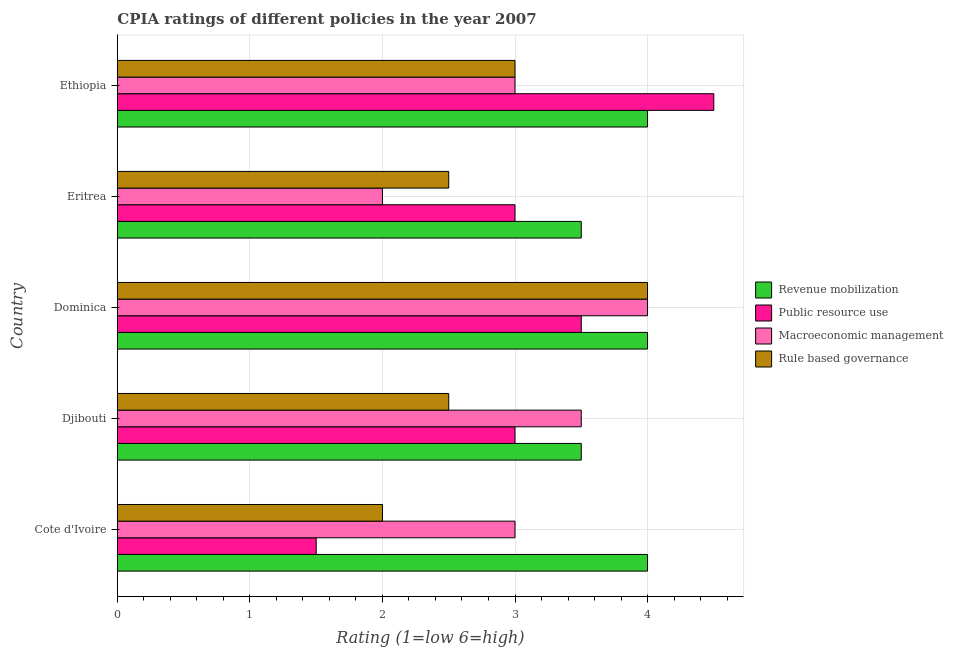How many bars are there on the 5th tick from the top?
Provide a succinct answer. 4. What is the label of the 3rd group of bars from the top?
Keep it short and to the point. Dominica. Across all countries, what is the maximum cpia rating of macroeconomic management?
Offer a terse response. 4. Across all countries, what is the minimum cpia rating of public resource use?
Provide a succinct answer. 1.5. In which country was the cpia rating of public resource use maximum?
Offer a terse response. Ethiopia. In which country was the cpia rating of revenue mobilization minimum?
Your answer should be compact. Djibouti. What is the total cpia rating of macroeconomic management in the graph?
Provide a succinct answer. 15.5. What is the difference between the cpia rating of revenue mobilization in Ethiopia and the cpia rating of macroeconomic management in Dominica?
Provide a succinct answer. 0. What is the ratio of the cpia rating of rule based governance in Dominica to that in Eritrea?
Your answer should be very brief. 1.6. Is the cpia rating of macroeconomic management in Cote d'Ivoire less than that in Ethiopia?
Your answer should be compact. No. What does the 2nd bar from the top in Eritrea represents?
Offer a terse response. Macroeconomic management. What does the 3rd bar from the bottom in Cote d'Ivoire represents?
Keep it short and to the point. Macroeconomic management. Is it the case that in every country, the sum of the cpia rating of revenue mobilization and cpia rating of public resource use is greater than the cpia rating of macroeconomic management?
Your answer should be compact. Yes. Are all the bars in the graph horizontal?
Ensure brevity in your answer.  Yes. What is the difference between two consecutive major ticks on the X-axis?
Offer a very short reply. 1. Does the graph contain any zero values?
Ensure brevity in your answer.  No. What is the title of the graph?
Make the answer very short. CPIA ratings of different policies in the year 2007. Does "Fish species" appear as one of the legend labels in the graph?
Your answer should be very brief. No. What is the label or title of the X-axis?
Make the answer very short. Rating (1=low 6=high). What is the label or title of the Y-axis?
Make the answer very short. Country. What is the Rating (1=low 6=high) of Revenue mobilization in Cote d'Ivoire?
Give a very brief answer. 4. What is the Rating (1=low 6=high) of Public resource use in Cote d'Ivoire?
Give a very brief answer. 1.5. What is the Rating (1=low 6=high) in Rule based governance in Cote d'Ivoire?
Make the answer very short. 2. What is the Rating (1=low 6=high) of Revenue mobilization in Djibouti?
Offer a very short reply. 3.5. What is the Rating (1=low 6=high) of Macroeconomic management in Djibouti?
Make the answer very short. 3.5. What is the Rating (1=low 6=high) in Revenue mobilization in Dominica?
Provide a succinct answer. 4. What is the Rating (1=low 6=high) in Public resource use in Dominica?
Your answer should be compact. 3.5. What is the Rating (1=low 6=high) of Revenue mobilization in Eritrea?
Your answer should be very brief. 3.5. What is the Rating (1=low 6=high) in Macroeconomic management in Eritrea?
Make the answer very short. 2. Across all countries, what is the maximum Rating (1=low 6=high) in Public resource use?
Provide a short and direct response. 4.5. Across all countries, what is the maximum Rating (1=low 6=high) of Macroeconomic management?
Provide a succinct answer. 4. Across all countries, what is the maximum Rating (1=low 6=high) of Rule based governance?
Offer a terse response. 4. Across all countries, what is the minimum Rating (1=low 6=high) of Public resource use?
Provide a succinct answer. 1.5. Across all countries, what is the minimum Rating (1=low 6=high) in Rule based governance?
Keep it short and to the point. 2. What is the total Rating (1=low 6=high) in Macroeconomic management in the graph?
Ensure brevity in your answer.  15.5. What is the total Rating (1=low 6=high) of Rule based governance in the graph?
Give a very brief answer. 14. What is the difference between the Rating (1=low 6=high) of Revenue mobilization in Cote d'Ivoire and that in Djibouti?
Provide a succinct answer. 0.5. What is the difference between the Rating (1=low 6=high) of Public resource use in Cote d'Ivoire and that in Djibouti?
Provide a short and direct response. -1.5. What is the difference between the Rating (1=low 6=high) of Macroeconomic management in Cote d'Ivoire and that in Djibouti?
Your answer should be compact. -0.5. What is the difference between the Rating (1=low 6=high) in Rule based governance in Cote d'Ivoire and that in Djibouti?
Offer a very short reply. -0.5. What is the difference between the Rating (1=low 6=high) of Revenue mobilization in Cote d'Ivoire and that in Dominica?
Your answer should be very brief. 0. What is the difference between the Rating (1=low 6=high) of Revenue mobilization in Cote d'Ivoire and that in Eritrea?
Your answer should be compact. 0.5. What is the difference between the Rating (1=low 6=high) of Public resource use in Cote d'Ivoire and that in Eritrea?
Your answer should be compact. -1.5. What is the difference between the Rating (1=low 6=high) of Rule based governance in Cote d'Ivoire and that in Eritrea?
Ensure brevity in your answer.  -0.5. What is the difference between the Rating (1=low 6=high) in Revenue mobilization in Cote d'Ivoire and that in Ethiopia?
Give a very brief answer. 0. What is the difference between the Rating (1=low 6=high) in Public resource use in Cote d'Ivoire and that in Ethiopia?
Offer a very short reply. -3. What is the difference between the Rating (1=low 6=high) of Macroeconomic management in Cote d'Ivoire and that in Ethiopia?
Offer a very short reply. 0. What is the difference between the Rating (1=low 6=high) of Rule based governance in Cote d'Ivoire and that in Ethiopia?
Keep it short and to the point. -1. What is the difference between the Rating (1=low 6=high) in Public resource use in Djibouti and that in Dominica?
Keep it short and to the point. -0.5. What is the difference between the Rating (1=low 6=high) of Revenue mobilization in Djibouti and that in Eritrea?
Provide a short and direct response. 0. What is the difference between the Rating (1=low 6=high) in Macroeconomic management in Djibouti and that in Eritrea?
Make the answer very short. 1.5. What is the difference between the Rating (1=low 6=high) of Rule based governance in Djibouti and that in Eritrea?
Offer a very short reply. 0. What is the difference between the Rating (1=low 6=high) in Macroeconomic management in Djibouti and that in Ethiopia?
Give a very brief answer. 0.5. What is the difference between the Rating (1=low 6=high) in Public resource use in Dominica and that in Eritrea?
Your answer should be compact. 0.5. What is the difference between the Rating (1=low 6=high) in Macroeconomic management in Dominica and that in Eritrea?
Keep it short and to the point. 2. What is the difference between the Rating (1=low 6=high) of Rule based governance in Dominica and that in Eritrea?
Offer a terse response. 1.5. What is the difference between the Rating (1=low 6=high) in Public resource use in Dominica and that in Ethiopia?
Make the answer very short. -1. What is the difference between the Rating (1=low 6=high) of Macroeconomic management in Dominica and that in Ethiopia?
Provide a short and direct response. 1. What is the difference between the Rating (1=low 6=high) of Rule based governance in Dominica and that in Ethiopia?
Make the answer very short. 1. What is the difference between the Rating (1=low 6=high) of Public resource use in Eritrea and that in Ethiopia?
Your response must be concise. -1.5. What is the difference between the Rating (1=low 6=high) of Rule based governance in Eritrea and that in Ethiopia?
Your answer should be compact. -0.5. What is the difference between the Rating (1=low 6=high) in Revenue mobilization in Cote d'Ivoire and the Rating (1=low 6=high) in Macroeconomic management in Djibouti?
Keep it short and to the point. 0.5. What is the difference between the Rating (1=low 6=high) of Revenue mobilization in Cote d'Ivoire and the Rating (1=low 6=high) of Rule based governance in Djibouti?
Offer a very short reply. 1.5. What is the difference between the Rating (1=low 6=high) in Public resource use in Cote d'Ivoire and the Rating (1=low 6=high) in Macroeconomic management in Djibouti?
Make the answer very short. -2. What is the difference between the Rating (1=low 6=high) of Public resource use in Cote d'Ivoire and the Rating (1=low 6=high) of Rule based governance in Djibouti?
Your answer should be very brief. -1. What is the difference between the Rating (1=low 6=high) of Revenue mobilization in Cote d'Ivoire and the Rating (1=low 6=high) of Public resource use in Dominica?
Keep it short and to the point. 0.5. What is the difference between the Rating (1=low 6=high) of Revenue mobilization in Cote d'Ivoire and the Rating (1=low 6=high) of Macroeconomic management in Dominica?
Give a very brief answer. 0. What is the difference between the Rating (1=low 6=high) in Public resource use in Cote d'Ivoire and the Rating (1=low 6=high) in Macroeconomic management in Dominica?
Offer a very short reply. -2.5. What is the difference between the Rating (1=low 6=high) in Public resource use in Cote d'Ivoire and the Rating (1=low 6=high) in Rule based governance in Dominica?
Your answer should be very brief. -2.5. What is the difference between the Rating (1=low 6=high) in Macroeconomic management in Cote d'Ivoire and the Rating (1=low 6=high) in Rule based governance in Dominica?
Provide a short and direct response. -1. What is the difference between the Rating (1=low 6=high) in Revenue mobilization in Cote d'Ivoire and the Rating (1=low 6=high) in Rule based governance in Eritrea?
Provide a short and direct response. 1.5. What is the difference between the Rating (1=low 6=high) of Revenue mobilization in Cote d'Ivoire and the Rating (1=low 6=high) of Rule based governance in Ethiopia?
Make the answer very short. 1. What is the difference between the Rating (1=low 6=high) of Public resource use in Cote d'Ivoire and the Rating (1=low 6=high) of Macroeconomic management in Ethiopia?
Keep it short and to the point. -1.5. What is the difference between the Rating (1=low 6=high) in Public resource use in Cote d'Ivoire and the Rating (1=low 6=high) in Rule based governance in Ethiopia?
Your answer should be very brief. -1.5. What is the difference between the Rating (1=low 6=high) of Revenue mobilization in Djibouti and the Rating (1=low 6=high) of Macroeconomic management in Dominica?
Offer a very short reply. -0.5. What is the difference between the Rating (1=low 6=high) of Revenue mobilization in Djibouti and the Rating (1=low 6=high) of Rule based governance in Dominica?
Ensure brevity in your answer.  -0.5. What is the difference between the Rating (1=low 6=high) of Revenue mobilization in Djibouti and the Rating (1=low 6=high) of Public resource use in Eritrea?
Provide a succinct answer. 0.5. What is the difference between the Rating (1=low 6=high) of Revenue mobilization in Djibouti and the Rating (1=low 6=high) of Rule based governance in Eritrea?
Ensure brevity in your answer.  1. What is the difference between the Rating (1=low 6=high) of Public resource use in Djibouti and the Rating (1=low 6=high) of Rule based governance in Eritrea?
Your answer should be compact. 0.5. What is the difference between the Rating (1=low 6=high) of Revenue mobilization in Djibouti and the Rating (1=low 6=high) of Macroeconomic management in Ethiopia?
Your answer should be compact. 0.5. What is the difference between the Rating (1=low 6=high) of Revenue mobilization in Djibouti and the Rating (1=low 6=high) of Rule based governance in Ethiopia?
Make the answer very short. 0.5. What is the difference between the Rating (1=low 6=high) of Public resource use in Djibouti and the Rating (1=low 6=high) of Rule based governance in Ethiopia?
Make the answer very short. 0. What is the difference between the Rating (1=low 6=high) of Macroeconomic management in Djibouti and the Rating (1=low 6=high) of Rule based governance in Ethiopia?
Give a very brief answer. 0.5. What is the difference between the Rating (1=low 6=high) of Revenue mobilization in Dominica and the Rating (1=low 6=high) of Public resource use in Eritrea?
Keep it short and to the point. 1. What is the difference between the Rating (1=low 6=high) of Revenue mobilization in Dominica and the Rating (1=low 6=high) of Macroeconomic management in Eritrea?
Make the answer very short. 2. What is the difference between the Rating (1=low 6=high) in Revenue mobilization in Dominica and the Rating (1=low 6=high) in Rule based governance in Eritrea?
Make the answer very short. 1.5. What is the difference between the Rating (1=low 6=high) of Public resource use in Dominica and the Rating (1=low 6=high) of Macroeconomic management in Eritrea?
Ensure brevity in your answer.  1.5. What is the difference between the Rating (1=low 6=high) in Public resource use in Dominica and the Rating (1=low 6=high) in Rule based governance in Eritrea?
Offer a terse response. 1. What is the difference between the Rating (1=low 6=high) in Macroeconomic management in Dominica and the Rating (1=low 6=high) in Rule based governance in Eritrea?
Keep it short and to the point. 1.5. What is the difference between the Rating (1=low 6=high) in Public resource use in Dominica and the Rating (1=low 6=high) in Rule based governance in Ethiopia?
Offer a very short reply. 0.5. What is the difference between the Rating (1=low 6=high) of Macroeconomic management in Dominica and the Rating (1=low 6=high) of Rule based governance in Ethiopia?
Offer a very short reply. 1. What is the difference between the Rating (1=low 6=high) of Public resource use in Eritrea and the Rating (1=low 6=high) of Macroeconomic management in Ethiopia?
Ensure brevity in your answer.  0. What is the difference between the Rating (1=low 6=high) in Macroeconomic management in Eritrea and the Rating (1=low 6=high) in Rule based governance in Ethiopia?
Provide a succinct answer. -1. What is the average Rating (1=low 6=high) of Public resource use per country?
Keep it short and to the point. 3.1. What is the difference between the Rating (1=low 6=high) in Revenue mobilization and Rating (1=low 6=high) in Macroeconomic management in Cote d'Ivoire?
Your answer should be compact. 1. What is the difference between the Rating (1=low 6=high) in Public resource use and Rating (1=low 6=high) in Macroeconomic management in Cote d'Ivoire?
Your answer should be very brief. -1.5. What is the difference between the Rating (1=low 6=high) of Revenue mobilization and Rating (1=low 6=high) of Public resource use in Djibouti?
Ensure brevity in your answer.  0.5. What is the difference between the Rating (1=low 6=high) in Macroeconomic management and Rating (1=low 6=high) in Rule based governance in Djibouti?
Your answer should be compact. 1. What is the difference between the Rating (1=low 6=high) in Revenue mobilization and Rating (1=low 6=high) in Macroeconomic management in Dominica?
Your answer should be compact. 0. What is the difference between the Rating (1=low 6=high) of Public resource use and Rating (1=low 6=high) of Rule based governance in Dominica?
Your answer should be very brief. -0.5. What is the difference between the Rating (1=low 6=high) in Revenue mobilization and Rating (1=low 6=high) in Rule based governance in Eritrea?
Provide a short and direct response. 1. What is the difference between the Rating (1=low 6=high) of Macroeconomic management and Rating (1=low 6=high) of Rule based governance in Eritrea?
Keep it short and to the point. -0.5. What is the difference between the Rating (1=low 6=high) in Revenue mobilization and Rating (1=low 6=high) in Public resource use in Ethiopia?
Provide a succinct answer. -0.5. What is the difference between the Rating (1=low 6=high) of Revenue mobilization and Rating (1=low 6=high) of Macroeconomic management in Ethiopia?
Make the answer very short. 1. What is the difference between the Rating (1=low 6=high) in Revenue mobilization and Rating (1=low 6=high) in Rule based governance in Ethiopia?
Ensure brevity in your answer.  1. What is the difference between the Rating (1=low 6=high) in Public resource use and Rating (1=low 6=high) in Rule based governance in Ethiopia?
Make the answer very short. 1.5. What is the ratio of the Rating (1=low 6=high) in Revenue mobilization in Cote d'Ivoire to that in Djibouti?
Make the answer very short. 1.14. What is the ratio of the Rating (1=low 6=high) in Public resource use in Cote d'Ivoire to that in Djibouti?
Provide a succinct answer. 0.5. What is the ratio of the Rating (1=low 6=high) in Rule based governance in Cote d'Ivoire to that in Djibouti?
Ensure brevity in your answer.  0.8. What is the ratio of the Rating (1=low 6=high) of Revenue mobilization in Cote d'Ivoire to that in Dominica?
Ensure brevity in your answer.  1. What is the ratio of the Rating (1=low 6=high) in Public resource use in Cote d'Ivoire to that in Dominica?
Provide a succinct answer. 0.43. What is the ratio of the Rating (1=low 6=high) of Public resource use in Cote d'Ivoire to that in Eritrea?
Provide a short and direct response. 0.5. What is the ratio of the Rating (1=low 6=high) of Rule based governance in Cote d'Ivoire to that in Eritrea?
Provide a short and direct response. 0.8. What is the ratio of the Rating (1=low 6=high) of Rule based governance in Cote d'Ivoire to that in Ethiopia?
Give a very brief answer. 0.67. What is the ratio of the Rating (1=low 6=high) of Revenue mobilization in Djibouti to that in Dominica?
Your answer should be compact. 0.88. What is the ratio of the Rating (1=low 6=high) in Public resource use in Djibouti to that in Dominica?
Give a very brief answer. 0.86. What is the ratio of the Rating (1=low 6=high) in Public resource use in Djibouti to that in Eritrea?
Your answer should be very brief. 1. What is the ratio of the Rating (1=low 6=high) in Rule based governance in Djibouti to that in Eritrea?
Your answer should be compact. 1. What is the ratio of the Rating (1=low 6=high) in Revenue mobilization in Dominica to that in Eritrea?
Offer a very short reply. 1.14. What is the ratio of the Rating (1=low 6=high) in Macroeconomic management in Dominica to that in Eritrea?
Offer a very short reply. 2. What is the ratio of the Rating (1=low 6=high) in Rule based governance in Dominica to that in Eritrea?
Offer a very short reply. 1.6. What is the ratio of the Rating (1=low 6=high) of Revenue mobilization in Dominica to that in Ethiopia?
Offer a very short reply. 1. What is the ratio of the Rating (1=low 6=high) in Public resource use in Dominica to that in Ethiopia?
Offer a terse response. 0.78. What is the ratio of the Rating (1=low 6=high) in Macroeconomic management in Dominica to that in Ethiopia?
Your answer should be very brief. 1.33. What is the ratio of the Rating (1=low 6=high) of Revenue mobilization in Eritrea to that in Ethiopia?
Make the answer very short. 0.88. What is the ratio of the Rating (1=low 6=high) in Macroeconomic management in Eritrea to that in Ethiopia?
Offer a very short reply. 0.67. What is the difference between the highest and the second highest Rating (1=low 6=high) in Public resource use?
Your answer should be very brief. 1. What is the difference between the highest and the second highest Rating (1=low 6=high) of Macroeconomic management?
Provide a short and direct response. 0.5. What is the difference between the highest and the second highest Rating (1=low 6=high) of Rule based governance?
Your answer should be compact. 1. What is the difference between the highest and the lowest Rating (1=low 6=high) in Public resource use?
Provide a short and direct response. 3. What is the difference between the highest and the lowest Rating (1=low 6=high) in Rule based governance?
Keep it short and to the point. 2. 